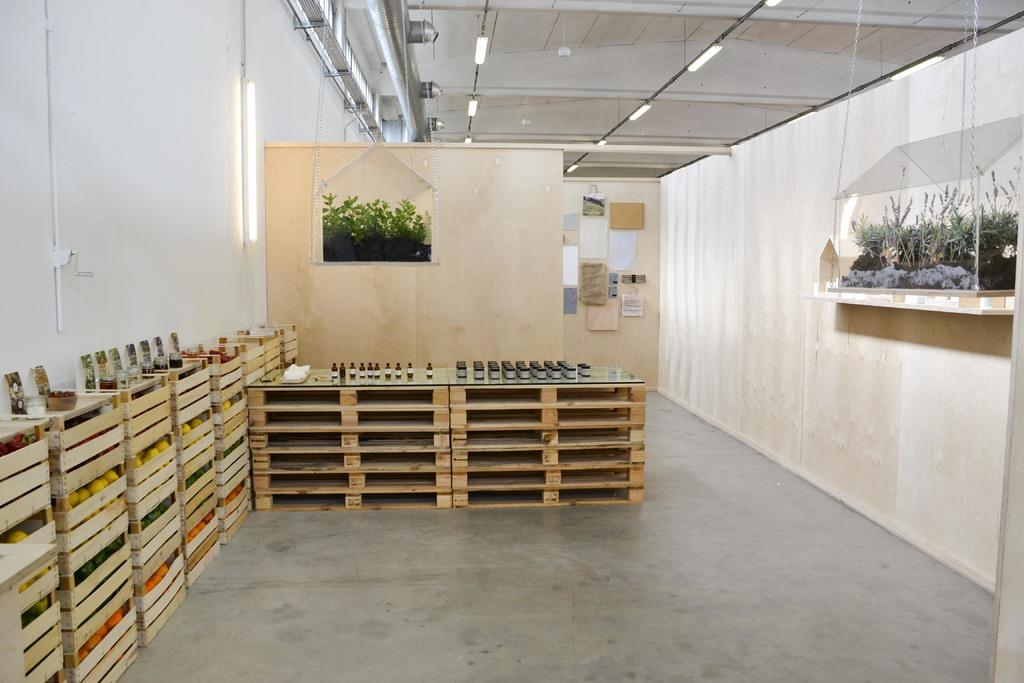What objects are present in the image? There are boxes, lights, and an aquarium in the image. Where are the lights located in the image? The lights are at the top of the image. What can be found on the right side of the image? There is an aquarium on the right side of the image. What type of jeans can be seen hanging on the coast in the image? There is no coast or jeans present in the image. 